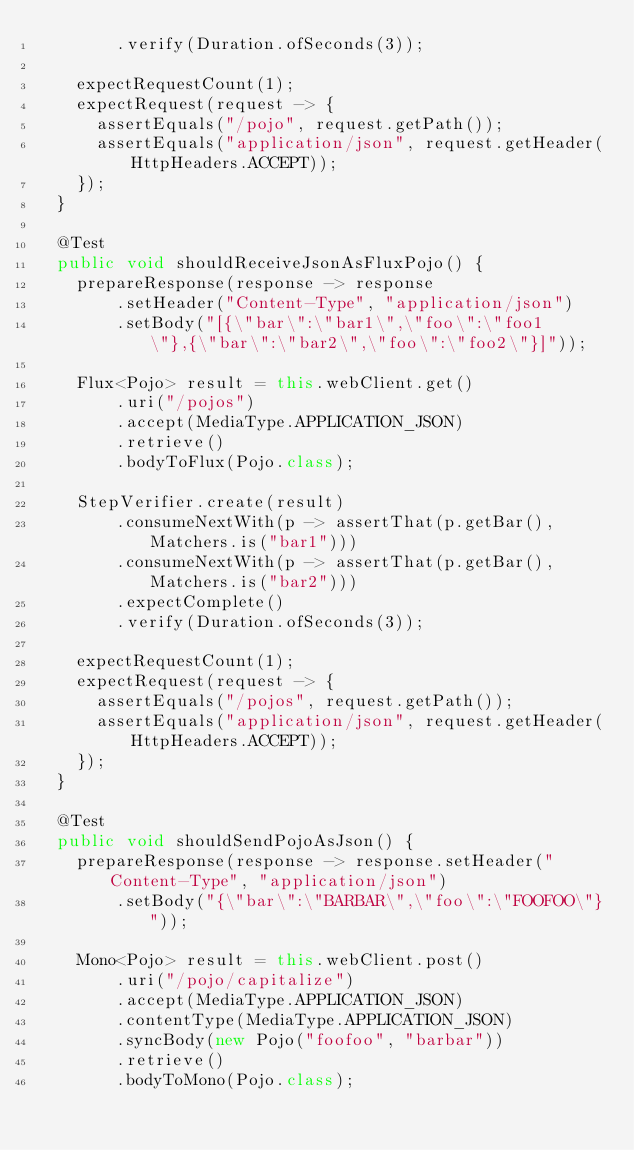Convert code to text. <code><loc_0><loc_0><loc_500><loc_500><_Java_>				.verify(Duration.ofSeconds(3));

		expectRequestCount(1);
		expectRequest(request -> {
			assertEquals("/pojo", request.getPath());
			assertEquals("application/json", request.getHeader(HttpHeaders.ACCEPT));
		});
	}

	@Test
	public void shouldReceiveJsonAsFluxPojo() {
		prepareResponse(response -> response
				.setHeader("Content-Type", "application/json")
				.setBody("[{\"bar\":\"bar1\",\"foo\":\"foo1\"},{\"bar\":\"bar2\",\"foo\":\"foo2\"}]"));

		Flux<Pojo> result = this.webClient.get()
				.uri("/pojos")
				.accept(MediaType.APPLICATION_JSON)
				.retrieve()
				.bodyToFlux(Pojo.class);

		StepVerifier.create(result)
				.consumeNextWith(p -> assertThat(p.getBar(), Matchers.is("bar1")))
				.consumeNextWith(p -> assertThat(p.getBar(), Matchers.is("bar2")))
				.expectComplete()
				.verify(Duration.ofSeconds(3));

		expectRequestCount(1);
		expectRequest(request -> {
			assertEquals("/pojos", request.getPath());
			assertEquals("application/json", request.getHeader(HttpHeaders.ACCEPT));
		});
	}

	@Test
	public void shouldSendPojoAsJson() {
		prepareResponse(response -> response.setHeader("Content-Type", "application/json")
				.setBody("{\"bar\":\"BARBAR\",\"foo\":\"FOOFOO\"}"));

		Mono<Pojo> result = this.webClient.post()
				.uri("/pojo/capitalize")
				.accept(MediaType.APPLICATION_JSON)
				.contentType(MediaType.APPLICATION_JSON)
				.syncBody(new Pojo("foofoo", "barbar"))
				.retrieve()
				.bodyToMono(Pojo.class);
</code> 